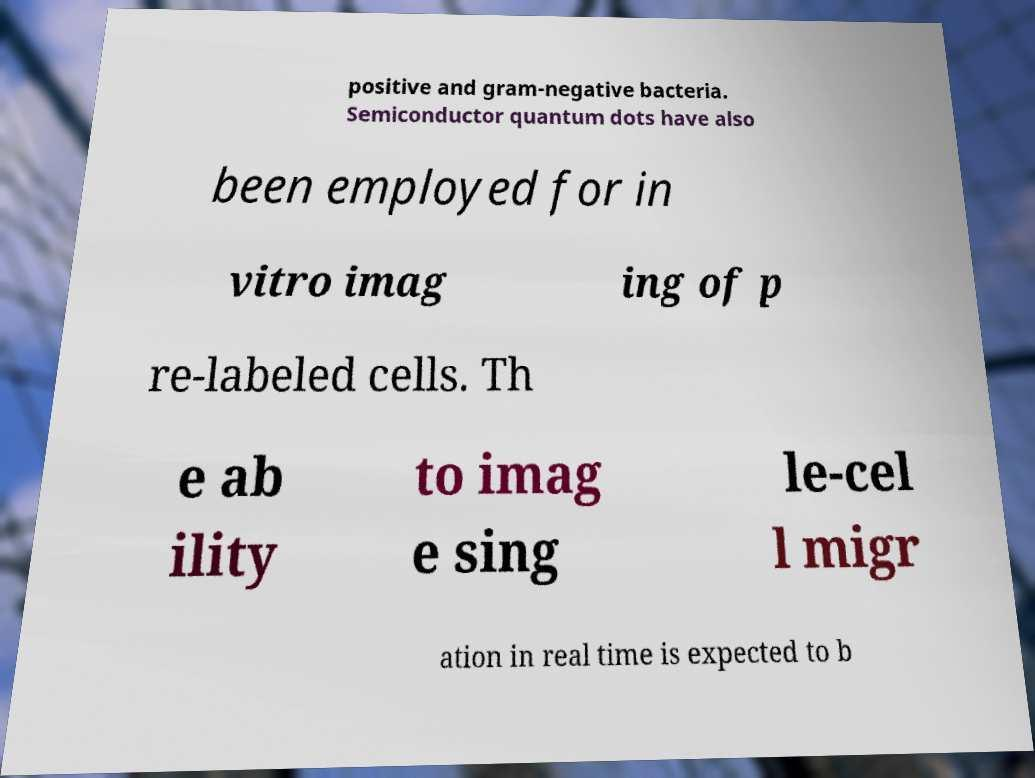Can you accurately transcribe the text from the provided image for me? positive and gram-negative bacteria. Semiconductor quantum dots have also been employed for in vitro imag ing of p re-labeled cells. Th e ab ility to imag e sing le-cel l migr ation in real time is expected to b 